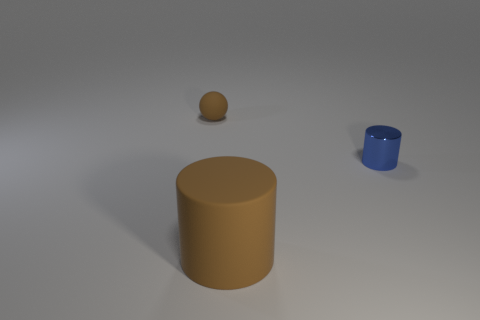Subtract 1 spheres. How many spheres are left? 0 Subtract all blue cylinders. How many cylinders are left? 1 Add 3 large purple metal blocks. How many objects exist? 6 Subtract 0 yellow cubes. How many objects are left? 3 Subtract all balls. How many objects are left? 2 Subtract all green spheres. Subtract all brown cubes. How many spheres are left? 1 Subtract all red cylinders. How many yellow spheres are left? 0 Subtract all big brown rubber cylinders. Subtract all brown matte cylinders. How many objects are left? 1 Add 2 blue cylinders. How many blue cylinders are left? 3 Add 3 large red cylinders. How many large red cylinders exist? 3 